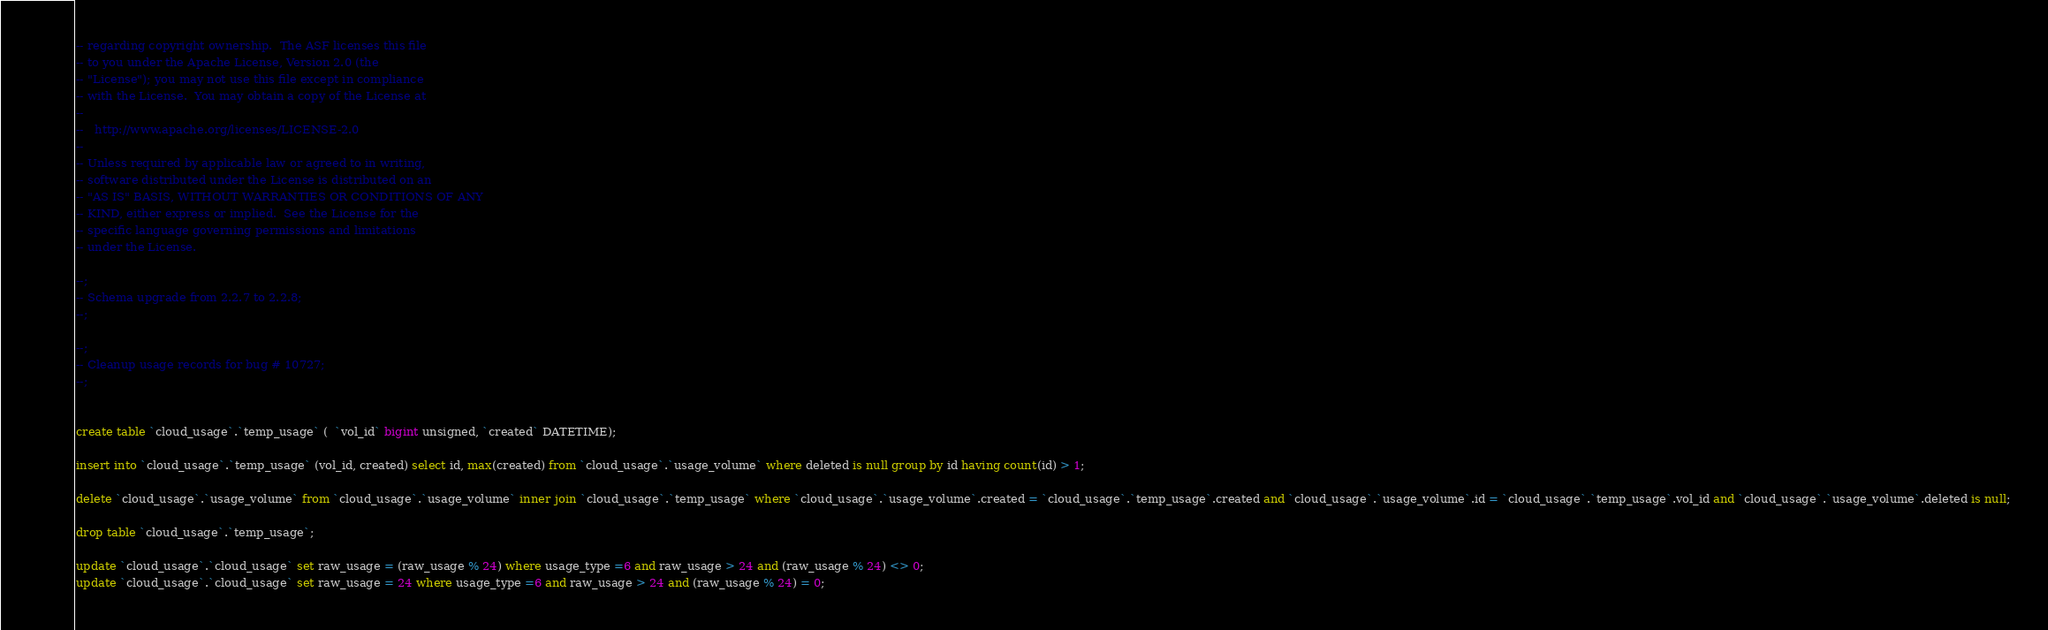<code> <loc_0><loc_0><loc_500><loc_500><_SQL_>-- regarding copyright ownership.  The ASF licenses this file
-- to you under the Apache License, Version 2.0 (the
-- "License"); you may not use this file except in compliance
-- with the License.  You may obtain a copy of the License at
-- 
--   http://www.apache.org/licenses/LICENSE-2.0
-- 
-- Unless required by applicable law or agreed to in writing,
-- software distributed under the License is distributed on an
-- "AS IS" BASIS, WITHOUT WARRANTIES OR CONDITIONS OF ANY
-- KIND, either express or implied.  See the License for the
-- specific language governing permissions and limitations
-- under the License.

--;
-- Schema upgrade from 2.2.7 to 2.2.8;
--;

--;
-- Cleanup usage records for bug # 10727;
--;


create table `cloud_usage`.`temp_usage` (  `vol_id` bigint unsigned, `created` DATETIME);

insert into `cloud_usage`.`temp_usage` (vol_id, created) select id, max(created) from `cloud_usage`.`usage_volume` where deleted is null group by id having count(id) > 1;

delete `cloud_usage`.`usage_volume` from `cloud_usage`.`usage_volume` inner join `cloud_usage`.`temp_usage` where `cloud_usage`.`usage_volume`.created = `cloud_usage`.`temp_usage`.created and `cloud_usage`.`usage_volume`.id = `cloud_usage`.`temp_usage`.vol_id and `cloud_usage`.`usage_volume`.deleted is null;

drop table `cloud_usage`.`temp_usage`;

update `cloud_usage`.`cloud_usage` set raw_usage = (raw_usage % 24) where usage_type =6 and raw_usage > 24 and (raw_usage % 24) <> 0;
update `cloud_usage`.`cloud_usage` set raw_usage = 24 where usage_type =6 and raw_usage > 24 and (raw_usage % 24) = 0;

</code> 